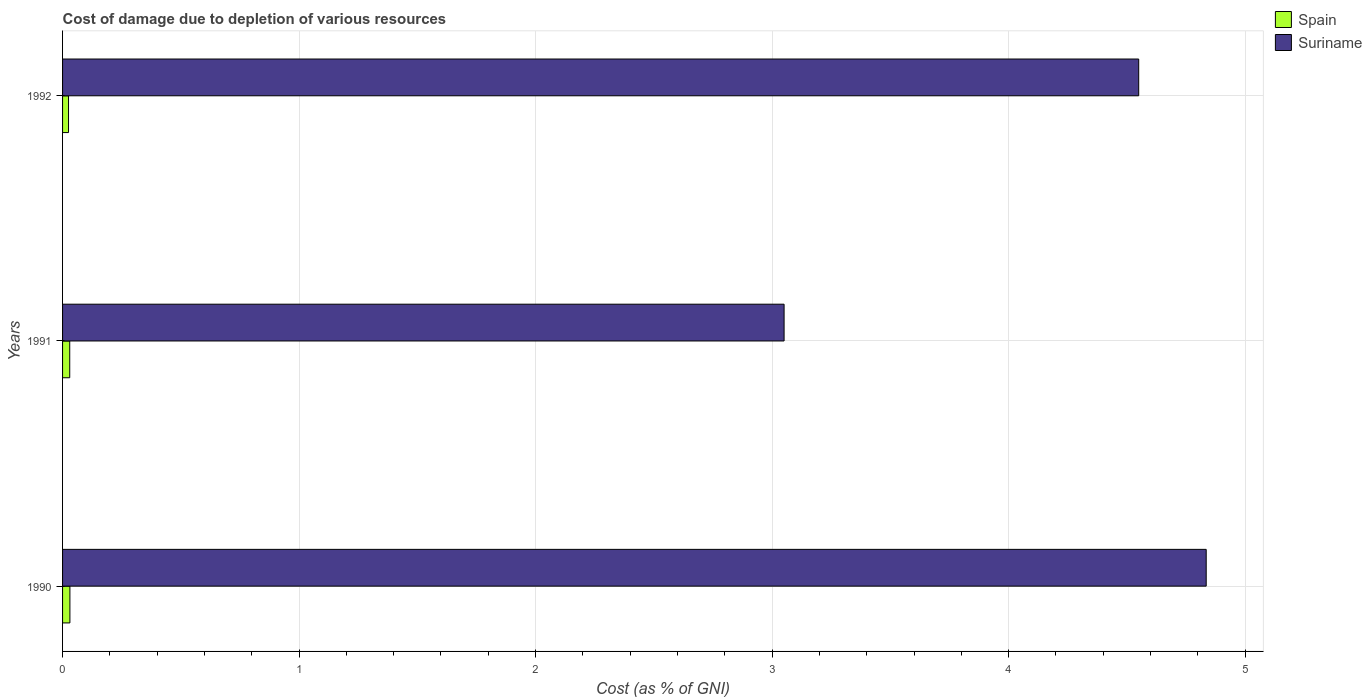How many groups of bars are there?
Ensure brevity in your answer.  3. Are the number of bars per tick equal to the number of legend labels?
Your answer should be very brief. Yes. Are the number of bars on each tick of the Y-axis equal?
Your answer should be very brief. Yes. What is the label of the 2nd group of bars from the top?
Make the answer very short. 1991. In how many cases, is the number of bars for a given year not equal to the number of legend labels?
Your answer should be very brief. 0. What is the cost of damage caused due to the depletion of various resources in Suriname in 1992?
Offer a very short reply. 4.55. Across all years, what is the maximum cost of damage caused due to the depletion of various resources in Suriname?
Your response must be concise. 4.84. Across all years, what is the minimum cost of damage caused due to the depletion of various resources in Suriname?
Provide a short and direct response. 3.05. In which year was the cost of damage caused due to the depletion of various resources in Suriname maximum?
Your response must be concise. 1990. In which year was the cost of damage caused due to the depletion of various resources in Spain minimum?
Offer a terse response. 1992. What is the total cost of damage caused due to the depletion of various resources in Spain in the graph?
Provide a short and direct response. 0.09. What is the difference between the cost of damage caused due to the depletion of various resources in Suriname in 1990 and that in 1991?
Keep it short and to the point. 1.78. What is the difference between the cost of damage caused due to the depletion of various resources in Spain in 1990 and the cost of damage caused due to the depletion of various resources in Suriname in 1992?
Make the answer very short. -4.52. What is the average cost of damage caused due to the depletion of various resources in Spain per year?
Make the answer very short. 0.03. In the year 1990, what is the difference between the cost of damage caused due to the depletion of various resources in Suriname and cost of damage caused due to the depletion of various resources in Spain?
Offer a terse response. 4.8. What is the ratio of the cost of damage caused due to the depletion of various resources in Suriname in 1990 to that in 1991?
Make the answer very short. 1.59. Is the difference between the cost of damage caused due to the depletion of various resources in Suriname in 1990 and 1992 greater than the difference between the cost of damage caused due to the depletion of various resources in Spain in 1990 and 1992?
Offer a terse response. Yes. What is the difference between the highest and the second highest cost of damage caused due to the depletion of various resources in Spain?
Make the answer very short. 0. What is the difference between the highest and the lowest cost of damage caused due to the depletion of various resources in Spain?
Offer a very short reply. 0.01. What does the 2nd bar from the top in 1990 represents?
Make the answer very short. Spain. What does the 1st bar from the bottom in 1991 represents?
Ensure brevity in your answer.  Spain. How many bars are there?
Give a very brief answer. 6. Are all the bars in the graph horizontal?
Keep it short and to the point. Yes. Are the values on the major ticks of X-axis written in scientific E-notation?
Offer a very short reply. No. Does the graph contain any zero values?
Provide a succinct answer. No. Where does the legend appear in the graph?
Keep it short and to the point. Top right. How are the legend labels stacked?
Your answer should be very brief. Vertical. What is the title of the graph?
Provide a short and direct response. Cost of damage due to depletion of various resources. Does "Bahrain" appear as one of the legend labels in the graph?
Offer a terse response. No. What is the label or title of the X-axis?
Your answer should be compact. Cost (as % of GNI). What is the label or title of the Y-axis?
Give a very brief answer. Years. What is the Cost (as % of GNI) of Spain in 1990?
Provide a succinct answer. 0.03. What is the Cost (as % of GNI) in Suriname in 1990?
Ensure brevity in your answer.  4.84. What is the Cost (as % of GNI) of Spain in 1991?
Ensure brevity in your answer.  0.03. What is the Cost (as % of GNI) in Suriname in 1991?
Your answer should be compact. 3.05. What is the Cost (as % of GNI) of Spain in 1992?
Provide a short and direct response. 0.03. What is the Cost (as % of GNI) in Suriname in 1992?
Provide a succinct answer. 4.55. Across all years, what is the maximum Cost (as % of GNI) of Spain?
Keep it short and to the point. 0.03. Across all years, what is the maximum Cost (as % of GNI) in Suriname?
Offer a terse response. 4.84. Across all years, what is the minimum Cost (as % of GNI) in Spain?
Your answer should be very brief. 0.03. Across all years, what is the minimum Cost (as % of GNI) in Suriname?
Your answer should be very brief. 3.05. What is the total Cost (as % of GNI) in Spain in the graph?
Offer a very short reply. 0.09. What is the total Cost (as % of GNI) in Suriname in the graph?
Your answer should be compact. 12.44. What is the difference between the Cost (as % of GNI) of Spain in 1990 and that in 1991?
Keep it short and to the point. 0. What is the difference between the Cost (as % of GNI) in Suriname in 1990 and that in 1991?
Provide a succinct answer. 1.78. What is the difference between the Cost (as % of GNI) of Spain in 1990 and that in 1992?
Provide a short and direct response. 0.01. What is the difference between the Cost (as % of GNI) of Suriname in 1990 and that in 1992?
Provide a short and direct response. 0.29. What is the difference between the Cost (as % of GNI) in Spain in 1991 and that in 1992?
Provide a succinct answer. 0.01. What is the difference between the Cost (as % of GNI) in Suriname in 1991 and that in 1992?
Your response must be concise. -1.5. What is the difference between the Cost (as % of GNI) in Spain in 1990 and the Cost (as % of GNI) in Suriname in 1991?
Give a very brief answer. -3.02. What is the difference between the Cost (as % of GNI) of Spain in 1990 and the Cost (as % of GNI) of Suriname in 1992?
Your response must be concise. -4.52. What is the difference between the Cost (as % of GNI) of Spain in 1991 and the Cost (as % of GNI) of Suriname in 1992?
Provide a short and direct response. -4.52. What is the average Cost (as % of GNI) in Spain per year?
Your answer should be compact. 0.03. What is the average Cost (as % of GNI) in Suriname per year?
Offer a very short reply. 4.15. In the year 1990, what is the difference between the Cost (as % of GNI) of Spain and Cost (as % of GNI) of Suriname?
Your response must be concise. -4.8. In the year 1991, what is the difference between the Cost (as % of GNI) in Spain and Cost (as % of GNI) in Suriname?
Provide a short and direct response. -3.02. In the year 1992, what is the difference between the Cost (as % of GNI) of Spain and Cost (as % of GNI) of Suriname?
Provide a succinct answer. -4.52. What is the ratio of the Cost (as % of GNI) in Spain in 1990 to that in 1991?
Make the answer very short. 1.02. What is the ratio of the Cost (as % of GNI) of Suriname in 1990 to that in 1991?
Provide a short and direct response. 1.58. What is the ratio of the Cost (as % of GNI) in Spain in 1990 to that in 1992?
Give a very brief answer. 1.23. What is the ratio of the Cost (as % of GNI) of Suriname in 1990 to that in 1992?
Offer a terse response. 1.06. What is the ratio of the Cost (as % of GNI) in Spain in 1991 to that in 1992?
Ensure brevity in your answer.  1.2. What is the ratio of the Cost (as % of GNI) in Suriname in 1991 to that in 1992?
Offer a terse response. 0.67. What is the difference between the highest and the second highest Cost (as % of GNI) of Spain?
Make the answer very short. 0. What is the difference between the highest and the second highest Cost (as % of GNI) in Suriname?
Keep it short and to the point. 0.29. What is the difference between the highest and the lowest Cost (as % of GNI) of Spain?
Your response must be concise. 0.01. What is the difference between the highest and the lowest Cost (as % of GNI) of Suriname?
Your response must be concise. 1.78. 